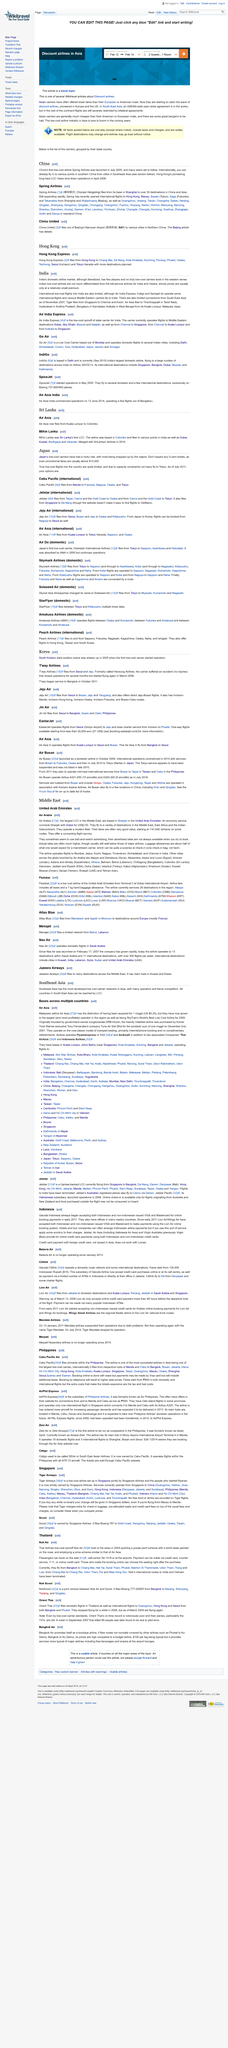Identify some key points in this picture. A tiger, originating from Singapore, traveled to the cities of Chennai and Kochi, where it resided. Yes, Spicejet operates international flights into India. Yes, low-cost flights are limited both domestically and internationally in India. 